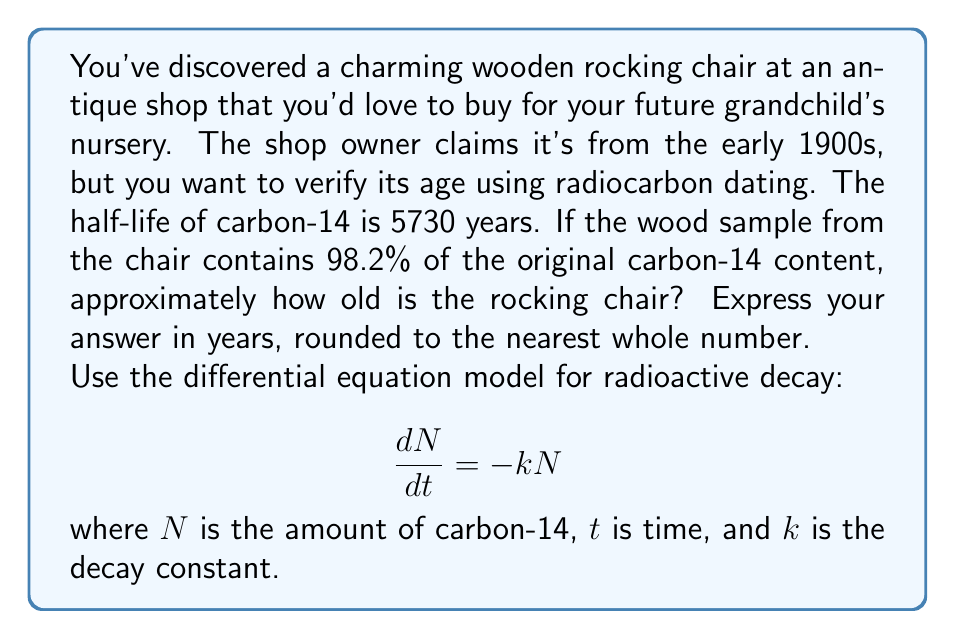Could you help me with this problem? Let's approach this step-by-step:

1) The differential equation for radioactive decay is:
   $$\frac{dN}{dt} = -kN$$

2) The solution to this equation is:
   $$N(t) = N_0e^{-kt}$$
   where $N_0$ is the initial amount of carbon-14.

3) We're given that 98.2% of the original carbon-14 remains. This means:
   $$\frac{N(t)}{N_0} = 0.982$$

4) Substituting this into our solution:
   $$0.982 = e^{-kt}$$

5) Taking the natural log of both sides:
   $$\ln(0.982) = -kt$$

6) Now we need to find $k$. We can use the half-life formula:
   $$T_{1/2} = \frac{\ln(2)}{k}$$

7) Rearranging to solve for $k$:
   $$k = \frac{\ln(2)}{T_{1/2}} = \frac{\ln(2)}{5730} \approx 0.000121$$

8) Now we can solve for $t$:
   $$t = -\frac{\ln(0.982)}{k} = -\frac{\ln(0.982)}{0.000121} \approx 150.4$$

9) Rounding to the nearest whole number:
   $$t \approx 150 \text{ years}$$
Answer: 150 years 